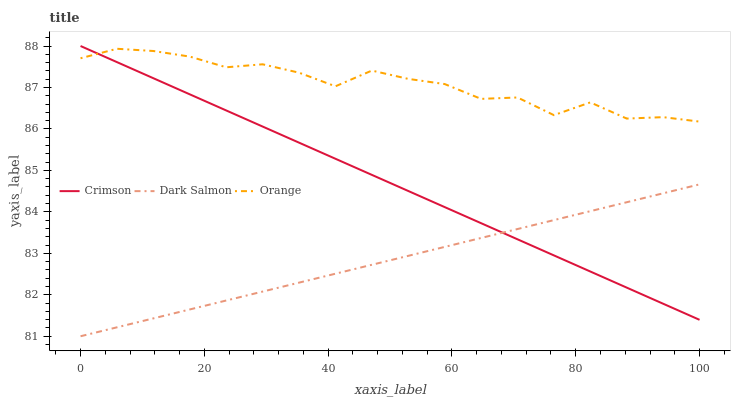Does Orange have the minimum area under the curve?
Answer yes or no. No. Does Dark Salmon have the maximum area under the curve?
Answer yes or no. No. Is Dark Salmon the smoothest?
Answer yes or no. No. Is Dark Salmon the roughest?
Answer yes or no. No. Does Orange have the lowest value?
Answer yes or no. No. Does Orange have the highest value?
Answer yes or no. No. Is Dark Salmon less than Orange?
Answer yes or no. Yes. Is Orange greater than Dark Salmon?
Answer yes or no. Yes. Does Dark Salmon intersect Orange?
Answer yes or no. No. 